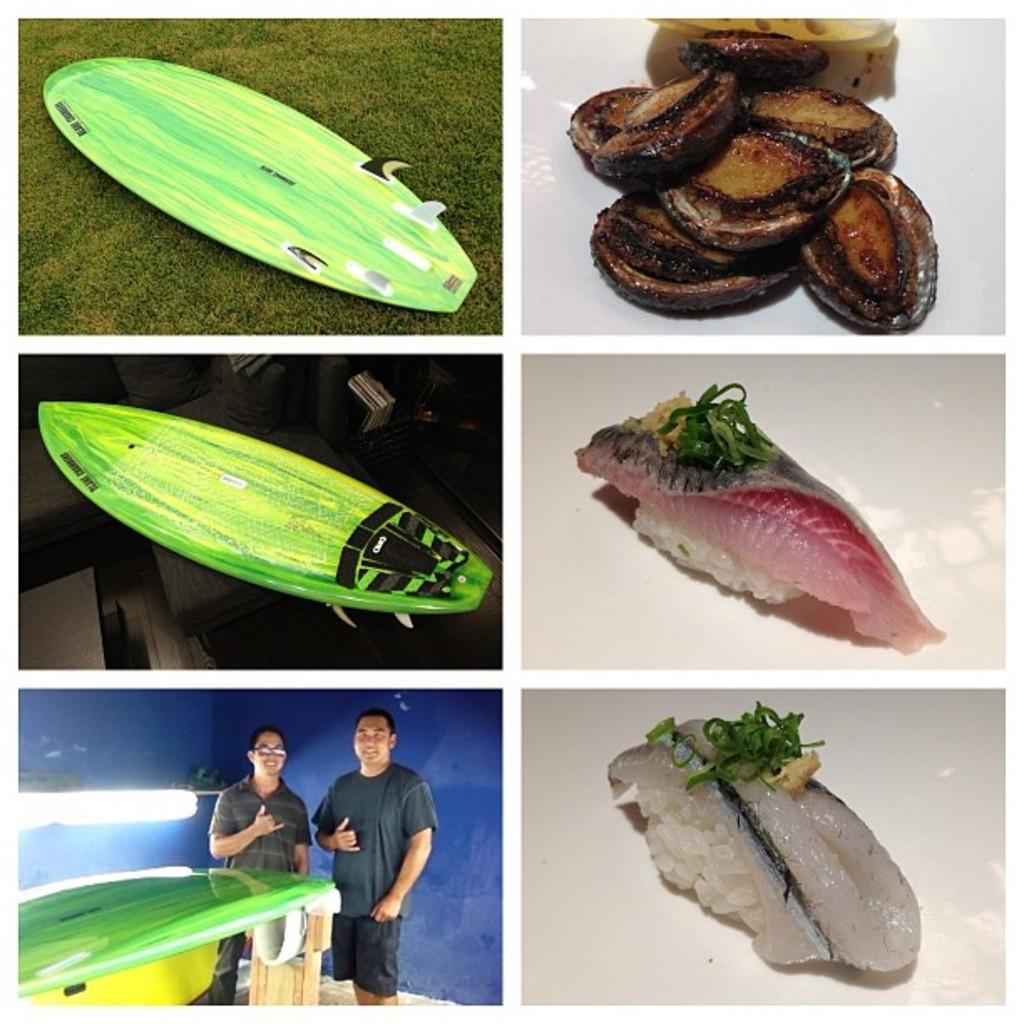Describe this image in one or two sentences. This is a collage of six images where we can see two persons, wooden objects and some food items. 